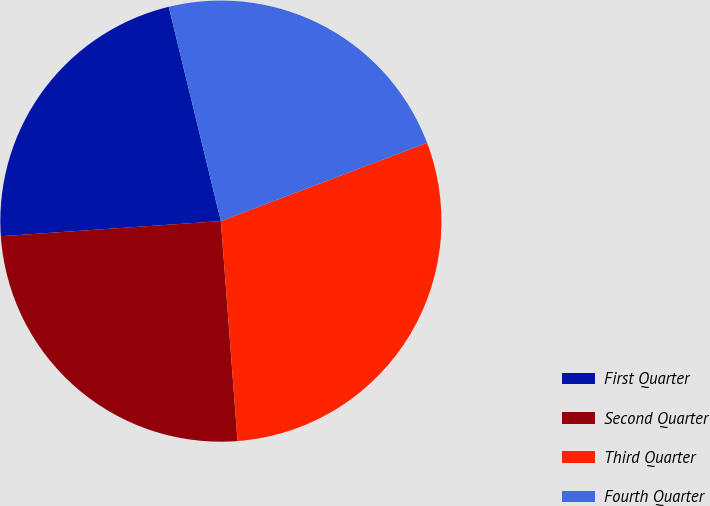<chart> <loc_0><loc_0><loc_500><loc_500><pie_chart><fcel>First Quarter<fcel>Second Quarter<fcel>Third Quarter<fcel>Fourth Quarter<nl><fcel>22.29%<fcel>25.11%<fcel>29.57%<fcel>23.02%<nl></chart> 